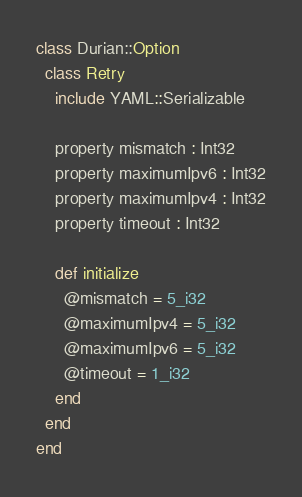Convert code to text. <code><loc_0><loc_0><loc_500><loc_500><_Crystal_>class Durian::Option
  class Retry
    include YAML::Serializable

    property mismatch : Int32
    property maximumIpv6 : Int32
    property maximumIpv4 : Int32
    property timeout : Int32

    def initialize
      @mismatch = 5_i32
      @maximumIpv4 = 5_i32
      @maximumIpv6 = 5_i32
      @timeout = 1_i32
    end
  end
end
</code> 